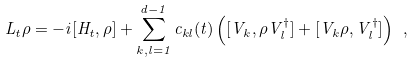<formula> <loc_0><loc_0><loc_500><loc_500>L _ { t } \rho = - i [ H _ { t } , \rho ] + \sum _ { k , l = 1 } ^ { d - 1 } c _ { k l } ( t ) \left ( [ V _ { k } , \rho V _ { l } ^ { \dagger } ] + [ V _ { k } \rho , V _ { l } ^ { \dagger } ] \right ) \ ,</formula> 